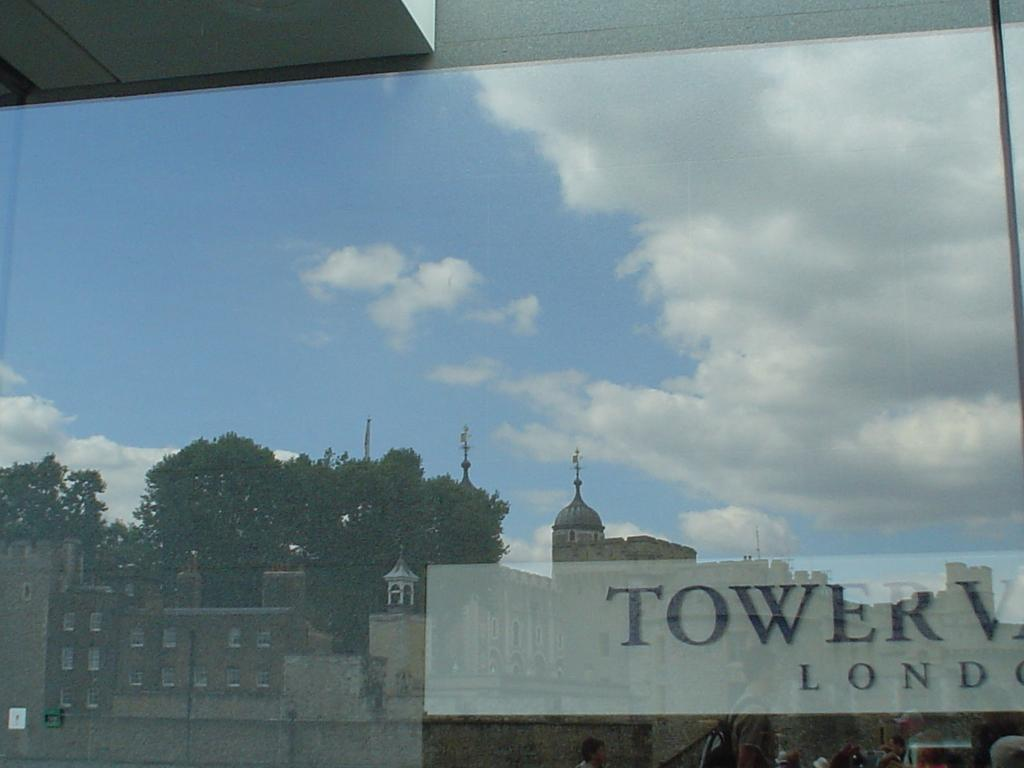<image>
Render a clear and concise summary of the photo. A window view of various buildings including the Tower of London. 